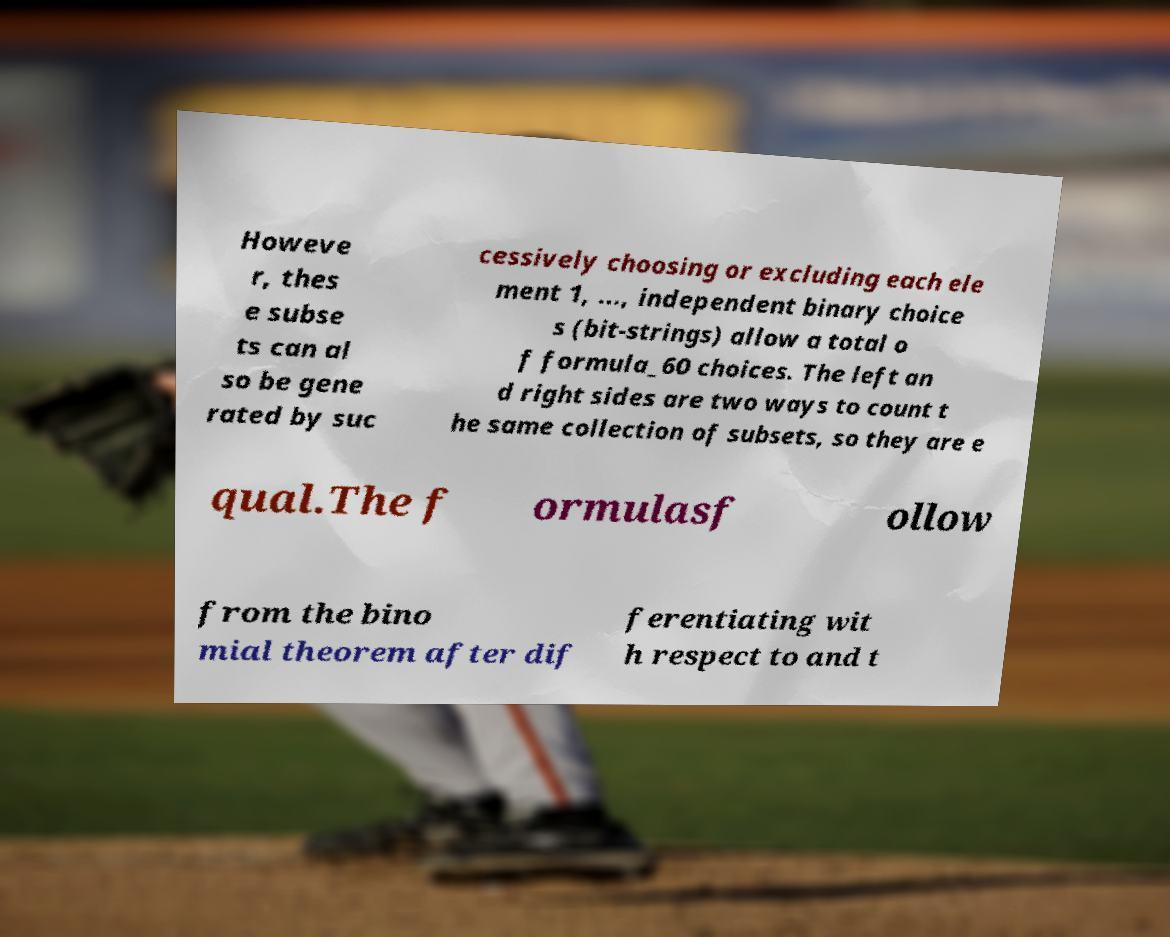There's text embedded in this image that I need extracted. Can you transcribe it verbatim? Howeve r, thes e subse ts can al so be gene rated by suc cessively choosing or excluding each ele ment 1, ..., independent binary choice s (bit-strings) allow a total o f formula_60 choices. The left an d right sides are two ways to count t he same collection of subsets, so they are e qual.The f ormulasf ollow from the bino mial theorem after dif ferentiating wit h respect to and t 